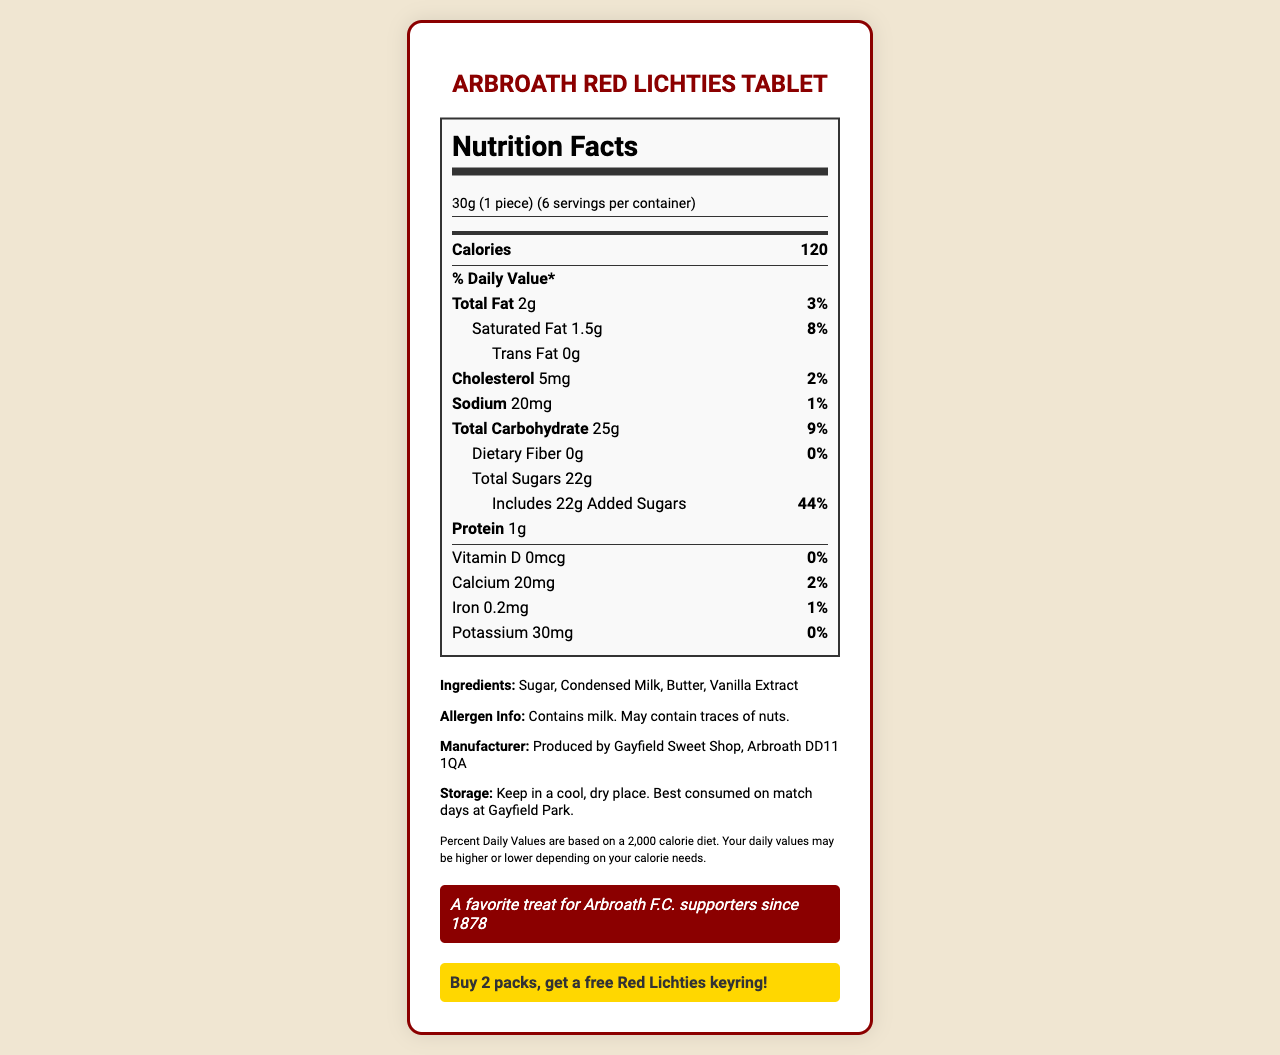what is the serving size? The serving size is listed in the document and is 30g, which is equivalent to one piece.
Answer: 30g (1 piece) how many servings are there per container? The document specifies that there are 6 servings per container.
Answer: 6 what is the calorie count per serving? The document states that each serving contains 120 calories.
Answer: 120 how much total fat is in one serving? The total fat amount for one serving is indicated as 2g in the document.
Answer: 2g what is the percent daily value of saturated fat per serving? The document shows that the percent daily value of saturated fat per serving is 8%.
Answer: 8% what is the amount of added sugars per serving? The document mentions that each serving includes 22g of added sugars.
Answer: 22g which nutrient has the lowest percentage daily value per serving? The document shows dietary fiber with a 0% daily value per serving.
Answer: Dietary Fiber what should you do to get a free Red Lichties keyring? The document details the matchday special, which is to buy 2 packs to receive a free Red Lichties keyring.
Answer: Buy 2 packs what allergens are in the tablet? The document lists that the tablet contains milk and may contain traces of nuts.
Answer: Milk what percentage of the daily value of total carbohydrate is in each serving? The document shows that each serving accounts for 9% of the daily value of total carbohydrates.
Answer: 9% which ingredient is not listed in the ingredient list? The document lists the ingredients as Sugar, Condensed Milk, Butter, and Vanilla Extract. Water is not mentioned.
Answer: Water what are the instructions for storing the Arbroath Red Lichties Tablet? The storage information from the document indicates to keep it in a cool, dry place, with a note that it is best consumed on match days at Gayfield Park.
Answer: Keep in a cool, dry place. Best consumed on match days at Gayfield Park. how much protein is there in a serving? The document specifies that there is 1 gram of protein per serving.
Answer: 1g what is the amount of sodium per serving? According to the document, each serving contains 20mg of sodium.
Answer: 20mg what vitamins are listed in the nutrition facts? The document lists Vitamin D, which has 0mcg and 0% daily value.
Answer: Vitamin D is the calorie count given for the entire container? (Yes/No) The calorie count given is per serving, as the document states 120 calories per serving and lists 6 servings per container.
Answer: No can you determine how many calories come from fat? The document does not provide the necessary details to calculate the calories that come specifically from fat.
Answer: Not enough information what is the main idea of the document? The document gives a comprehensive nutrition breakdown of the Arbroath Red Lichties Tablet, including serving size, nutrient content, ingredients, allergens, and additional buying information.
Answer: The document provides detailed nutrition facts and additional information about the Arbroath Red Lichties Tablet, highlighting its high sugar content, serving size, and promoting a special deal for fans of Arbroath F.C. 